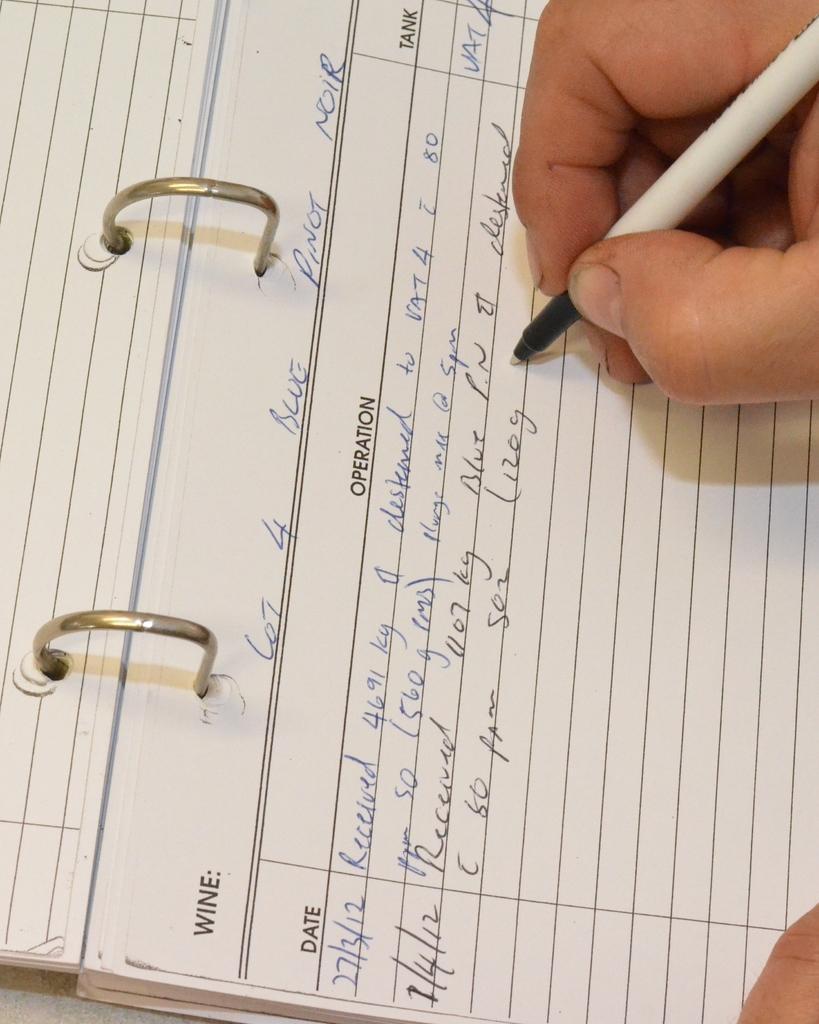Can you describe this image briefly? In this image, we can see a notepad and there is a person's hand holding a pen. 